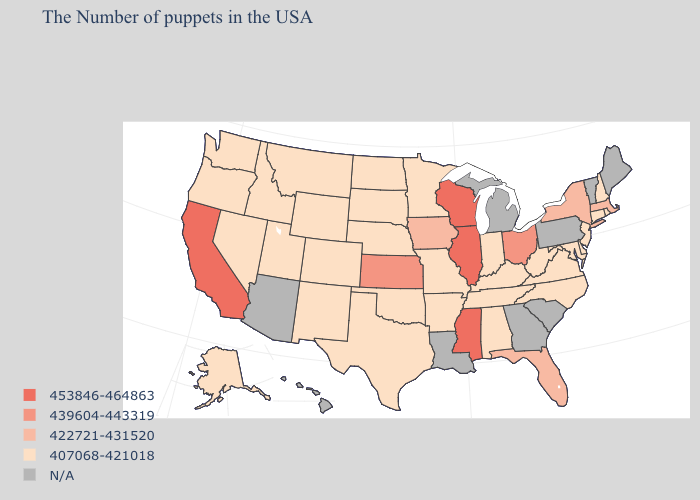What is the lowest value in states that border Mississippi?
Write a very short answer. 407068-421018. Name the states that have a value in the range 439604-443319?
Be succinct. Ohio, Kansas. Name the states that have a value in the range 407068-421018?
Quick response, please. Rhode Island, New Hampshire, Connecticut, New Jersey, Delaware, Maryland, Virginia, North Carolina, West Virginia, Kentucky, Indiana, Alabama, Tennessee, Missouri, Arkansas, Minnesota, Nebraska, Oklahoma, Texas, South Dakota, North Dakota, Wyoming, Colorado, New Mexico, Utah, Montana, Idaho, Nevada, Washington, Oregon, Alaska. What is the value of Missouri?
Quick response, please. 407068-421018. Is the legend a continuous bar?
Keep it brief. No. What is the value of Rhode Island?
Short answer required. 407068-421018. What is the lowest value in the Northeast?
Concise answer only. 407068-421018. What is the value of Maryland?
Quick response, please. 407068-421018. Among the states that border Alabama , does Tennessee have the highest value?
Be succinct. No. Name the states that have a value in the range 453846-464863?
Answer briefly. Wisconsin, Illinois, Mississippi, California. What is the value of Rhode Island?
Quick response, please. 407068-421018. What is the value of Vermont?
Be succinct. N/A. Among the states that border Montana , which have the lowest value?
Keep it brief. South Dakota, North Dakota, Wyoming, Idaho. 